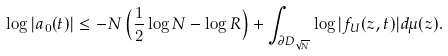<formula> <loc_0><loc_0><loc_500><loc_500>\log | a _ { 0 } ( t ) | \leq - N \left ( \frac { 1 } { 2 } \log N - \log R \right ) + \int _ { \partial D _ { \sqrt { N } } } \log | f _ { U } ( z , t ) | d \mu ( z ) .</formula> 